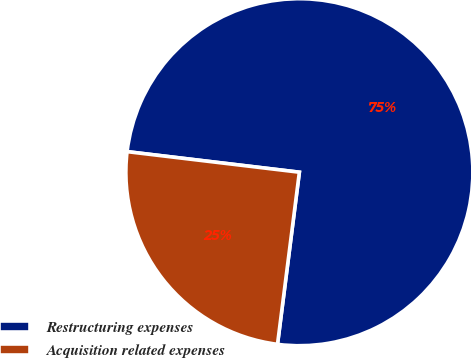Convert chart. <chart><loc_0><loc_0><loc_500><loc_500><pie_chart><fcel>Restructuring expenses<fcel>Acquisition related expenses<nl><fcel>75.12%<fcel>24.88%<nl></chart> 